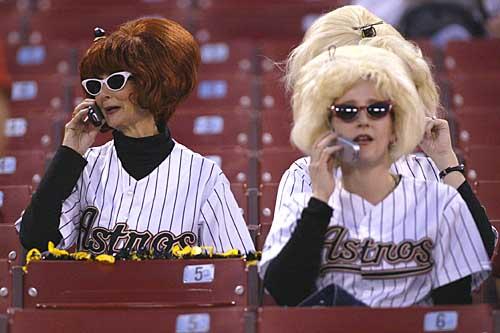What team is the women fans of?
Answer briefly. Astros. Is this their real hair?
Answer briefly. No. Are these women using video chat?
Short answer required. No. 